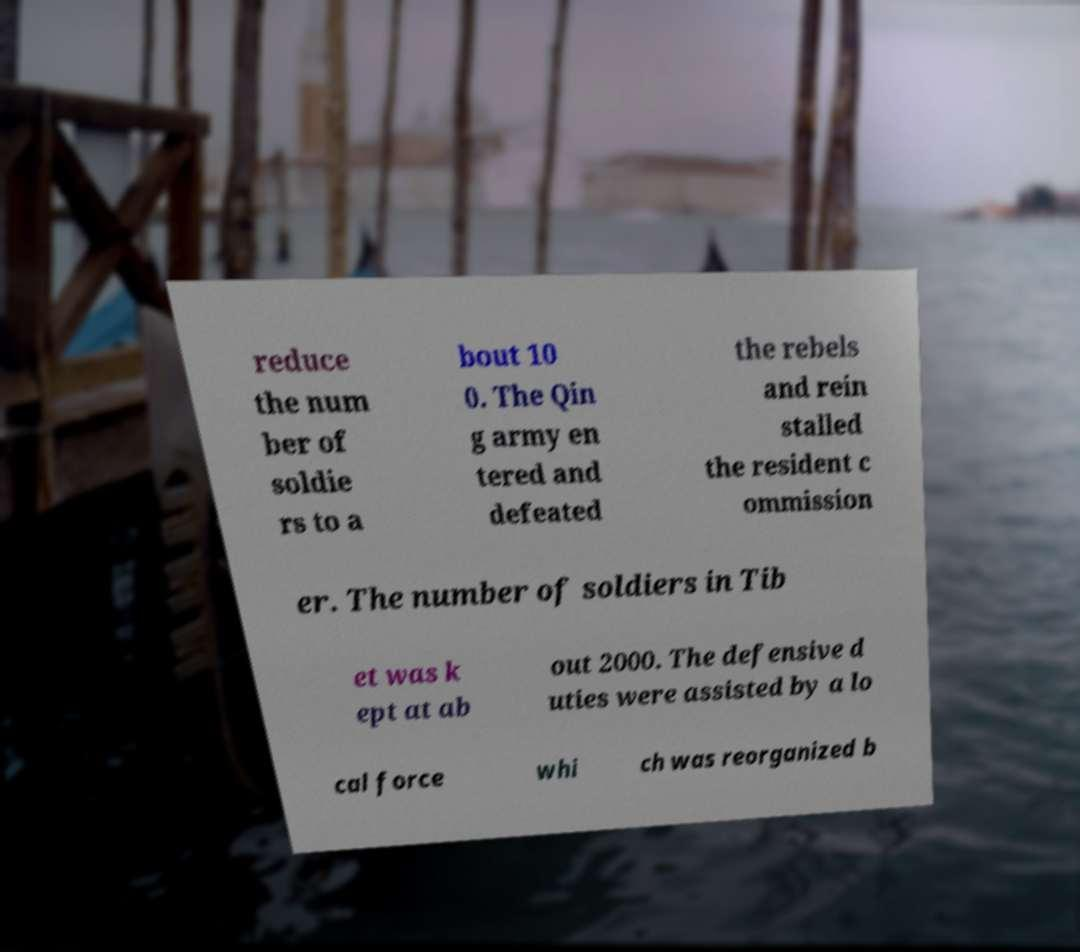There's text embedded in this image that I need extracted. Can you transcribe it verbatim? reduce the num ber of soldie rs to a bout 10 0. The Qin g army en tered and defeated the rebels and rein stalled the resident c ommission er. The number of soldiers in Tib et was k ept at ab out 2000. The defensive d uties were assisted by a lo cal force whi ch was reorganized b 